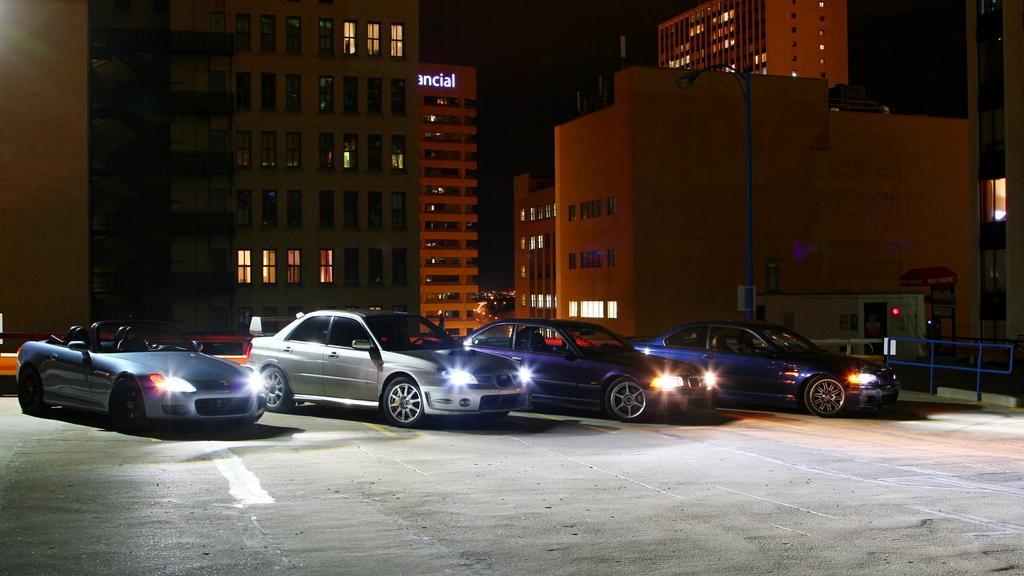How would you summarize this image in a sentence or two? In this image in the center there are some buildings, vehicles, railing, poles, boards and some lights. At the top there is sky, and at the bottom there is walkway. 